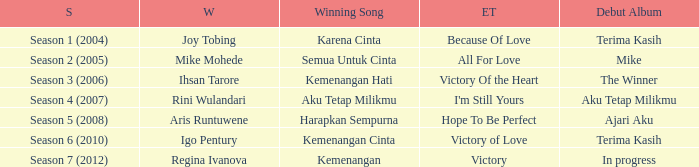Which winning song was sung by aku tetap milikmu? I'm Still Yours. 